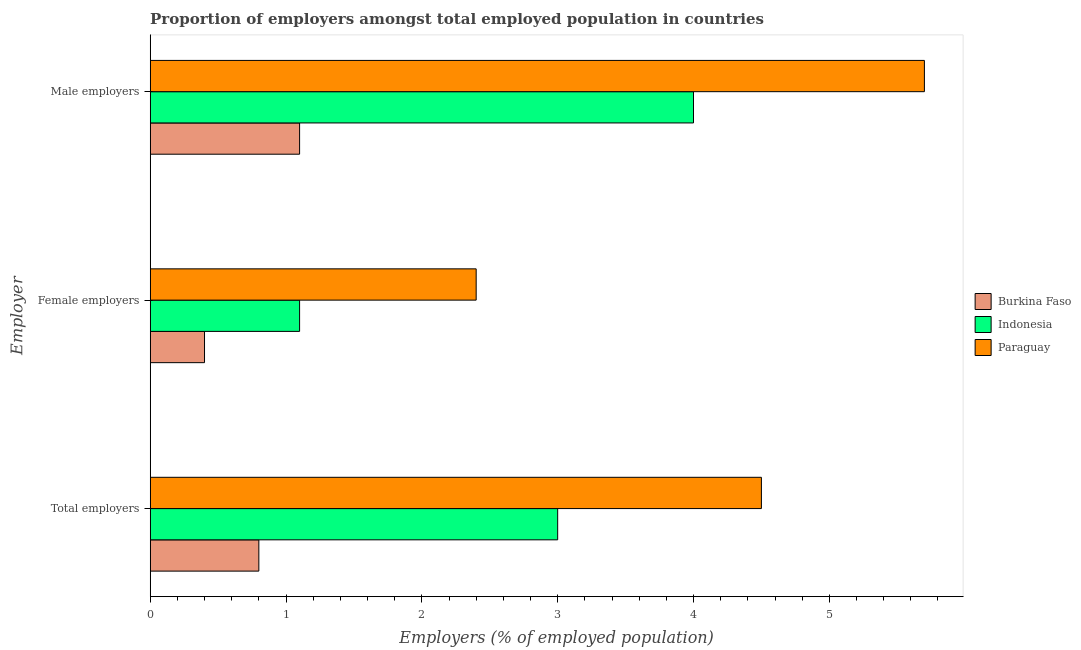How many different coloured bars are there?
Your answer should be very brief. 3. How many groups of bars are there?
Provide a succinct answer. 3. Are the number of bars per tick equal to the number of legend labels?
Make the answer very short. Yes. What is the label of the 1st group of bars from the top?
Provide a short and direct response. Male employers. What is the percentage of female employers in Paraguay?
Keep it short and to the point. 2.4. Across all countries, what is the maximum percentage of female employers?
Keep it short and to the point. 2.4. Across all countries, what is the minimum percentage of female employers?
Offer a very short reply. 0.4. In which country was the percentage of female employers maximum?
Your answer should be compact. Paraguay. In which country was the percentage of male employers minimum?
Your response must be concise. Burkina Faso. What is the total percentage of total employers in the graph?
Provide a short and direct response. 8.3. What is the difference between the percentage of female employers in Burkina Faso and that in Paraguay?
Your response must be concise. -2. What is the difference between the percentage of total employers in Paraguay and the percentage of male employers in Indonesia?
Provide a succinct answer. 0.5. What is the average percentage of total employers per country?
Ensure brevity in your answer.  2.77. What is the difference between the percentage of total employers and percentage of male employers in Paraguay?
Offer a very short reply. -1.2. What is the ratio of the percentage of male employers in Paraguay to that in Indonesia?
Provide a short and direct response. 1.42. What is the difference between the highest and the second highest percentage of female employers?
Make the answer very short. 1.3. What is the difference between the highest and the lowest percentage of female employers?
Make the answer very short. 2. What does the 2nd bar from the top in Female employers represents?
Ensure brevity in your answer.  Indonesia. What does the 2nd bar from the bottom in Female employers represents?
Keep it short and to the point. Indonesia. Is it the case that in every country, the sum of the percentage of total employers and percentage of female employers is greater than the percentage of male employers?
Offer a very short reply. Yes. Are all the bars in the graph horizontal?
Offer a terse response. Yes. How many countries are there in the graph?
Ensure brevity in your answer.  3. Does the graph contain any zero values?
Offer a very short reply. No. Where does the legend appear in the graph?
Provide a succinct answer. Center right. How are the legend labels stacked?
Your answer should be compact. Vertical. What is the title of the graph?
Provide a succinct answer. Proportion of employers amongst total employed population in countries. What is the label or title of the X-axis?
Keep it short and to the point. Employers (% of employed population). What is the label or title of the Y-axis?
Provide a short and direct response. Employer. What is the Employers (% of employed population) of Burkina Faso in Total employers?
Provide a short and direct response. 0.8. What is the Employers (% of employed population) of Indonesia in Total employers?
Offer a very short reply. 3. What is the Employers (% of employed population) in Paraguay in Total employers?
Offer a terse response. 4.5. What is the Employers (% of employed population) in Burkina Faso in Female employers?
Provide a succinct answer. 0.4. What is the Employers (% of employed population) of Indonesia in Female employers?
Your answer should be compact. 1.1. What is the Employers (% of employed population) of Paraguay in Female employers?
Ensure brevity in your answer.  2.4. What is the Employers (% of employed population) in Burkina Faso in Male employers?
Offer a terse response. 1.1. What is the Employers (% of employed population) of Paraguay in Male employers?
Offer a terse response. 5.7. Across all Employer, what is the maximum Employers (% of employed population) of Burkina Faso?
Offer a terse response. 1.1. Across all Employer, what is the maximum Employers (% of employed population) of Paraguay?
Offer a terse response. 5.7. Across all Employer, what is the minimum Employers (% of employed population) of Burkina Faso?
Give a very brief answer. 0.4. Across all Employer, what is the minimum Employers (% of employed population) in Indonesia?
Ensure brevity in your answer.  1.1. Across all Employer, what is the minimum Employers (% of employed population) of Paraguay?
Ensure brevity in your answer.  2.4. What is the total Employers (% of employed population) in Burkina Faso in the graph?
Your answer should be very brief. 2.3. What is the total Employers (% of employed population) of Paraguay in the graph?
Offer a terse response. 12.6. What is the difference between the Employers (% of employed population) of Indonesia in Total employers and that in Female employers?
Your answer should be compact. 1.9. What is the difference between the Employers (% of employed population) of Indonesia in Total employers and that in Male employers?
Give a very brief answer. -1. What is the difference between the Employers (% of employed population) of Paraguay in Total employers and that in Male employers?
Your response must be concise. -1.2. What is the difference between the Employers (% of employed population) in Burkina Faso in Female employers and that in Male employers?
Give a very brief answer. -0.7. What is the difference between the Employers (% of employed population) of Indonesia in Female employers and that in Male employers?
Give a very brief answer. -2.9. What is the difference between the Employers (% of employed population) in Burkina Faso in Total employers and the Employers (% of employed population) in Indonesia in Female employers?
Make the answer very short. -0.3. What is the difference between the Employers (% of employed population) in Burkina Faso in Total employers and the Employers (% of employed population) in Paraguay in Female employers?
Your answer should be compact. -1.6. What is the difference between the Employers (% of employed population) in Indonesia in Total employers and the Employers (% of employed population) in Paraguay in Female employers?
Make the answer very short. 0.6. What is the difference between the Employers (% of employed population) in Burkina Faso in Female employers and the Employers (% of employed population) in Indonesia in Male employers?
Give a very brief answer. -3.6. What is the difference between the Employers (% of employed population) in Indonesia in Female employers and the Employers (% of employed population) in Paraguay in Male employers?
Your answer should be very brief. -4.6. What is the average Employers (% of employed population) of Burkina Faso per Employer?
Provide a short and direct response. 0.77. What is the average Employers (% of employed population) in Indonesia per Employer?
Ensure brevity in your answer.  2.7. What is the difference between the Employers (% of employed population) in Indonesia and Employers (% of employed population) in Paraguay in Total employers?
Ensure brevity in your answer.  -1.5. What is the difference between the Employers (% of employed population) of Burkina Faso and Employers (% of employed population) of Indonesia in Male employers?
Give a very brief answer. -2.9. What is the difference between the Employers (% of employed population) of Burkina Faso and Employers (% of employed population) of Paraguay in Male employers?
Keep it short and to the point. -4.6. What is the ratio of the Employers (% of employed population) in Indonesia in Total employers to that in Female employers?
Your response must be concise. 2.73. What is the ratio of the Employers (% of employed population) in Paraguay in Total employers to that in Female employers?
Ensure brevity in your answer.  1.88. What is the ratio of the Employers (% of employed population) of Burkina Faso in Total employers to that in Male employers?
Make the answer very short. 0.73. What is the ratio of the Employers (% of employed population) in Paraguay in Total employers to that in Male employers?
Ensure brevity in your answer.  0.79. What is the ratio of the Employers (% of employed population) in Burkina Faso in Female employers to that in Male employers?
Provide a short and direct response. 0.36. What is the ratio of the Employers (% of employed population) of Indonesia in Female employers to that in Male employers?
Provide a succinct answer. 0.28. What is the ratio of the Employers (% of employed population) in Paraguay in Female employers to that in Male employers?
Provide a succinct answer. 0.42. What is the difference between the highest and the second highest Employers (% of employed population) of Indonesia?
Provide a succinct answer. 1. 